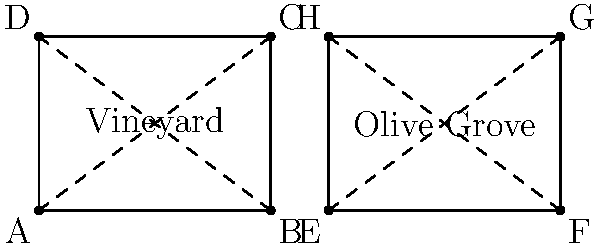Given the irrigation system layouts for adjacent vineyard and olive grove sections as shown in the diagram, are the two quadrilaterals ABCD and EFGH congruent? If so, state the congruence criterion used to prove it. To determine if quadrilaterals ABCD and EFGH are congruent, we need to follow these steps:

1. Identify the properties of each quadrilateral:
   - ABCD is a rectangle (all angles are 90°)
   - EFGH is also a rectangle (all angles are 90°)

2. Compare the side lengths:
   - AB = 4 units, BC = 3 units
   - EF = 4 units, FG = 3 units

3. Check if corresponding sides are equal:
   - AB = EF (4 units)
   - BC = FG (3 units)
   - CD = GH (4 units)
   - DA = HE (3 units)

4. Verify that all angles are 90° in both quadrilaterals.

5. Apply the congruence criterion:
   Since all corresponding sides are equal and all angles are right angles, we can use the Side-Angle-Side (SAS) congruence criterion to prove that the quadrilaterals are congruent.

Therefore, quadrilaterals ABCD and EFGH are congruent by the SAS (Side-Angle-Side) congruence criterion.
Answer: Yes, SAS congruence criterion 